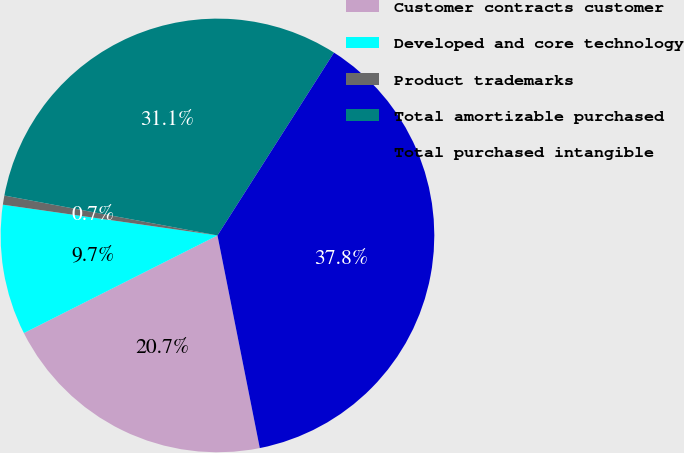Convert chart to OTSL. <chart><loc_0><loc_0><loc_500><loc_500><pie_chart><fcel>Customer contracts customer<fcel>Developed and core technology<fcel>Product trademarks<fcel>Total amortizable purchased<fcel>Total purchased intangible<nl><fcel>20.69%<fcel>9.7%<fcel>0.68%<fcel>31.08%<fcel>37.84%<nl></chart> 